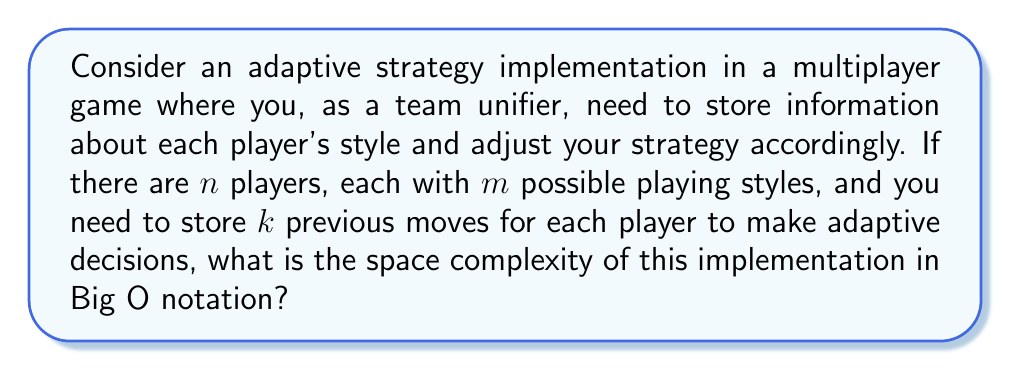Teach me how to tackle this problem. To solve this problem, let's break it down step-by-step:

1. Player information:
   - There are $n$ players in the game.
   - Each player has $m$ possible playing styles.
   - We need to store information about each player's current style.
   Space required: $O(n)$

2. Playing style information:
   - For each player, we need to store which of the $m$ styles they are currently using.
   - This can be represented by a single integer or enum for each player.
   Space required: $O(n)$ (combined with player information)

3. Previous moves:
   - We need to store $k$ previous moves for each player.
   - Each move can be represented by a constant amount of information.
   Space required: $O(n \cdot k)$

4. Adaptive strategy:
   - To implement the adaptive strategy, we might need a lookup table or decision matrix.
   - This would typically be based on the number of players and styles.
   Space required: $O(n \cdot m)$

Now, let's combine these components:

Total space complexity = $O(n) + O(n \cdot k) + O(n \cdot m)$

Since we're using Big O notation, we can simplify this by keeping the term with the highest growth rate. The dominant term will depend on the relative sizes of $k$ and $m$:

If $k \geq m$: $O(n \cdot k)$
If $m > k$: $O(n \cdot m)$

To cover both cases, we can express the final space complexity as:

$$O(n \cdot \max(k, m))$$

This notation indicates that the space complexity grows linearly with the number of players and with the larger of either the number of stored previous moves or the number of possible playing styles.
Answer: $O(n \cdot \max(k, m))$ 